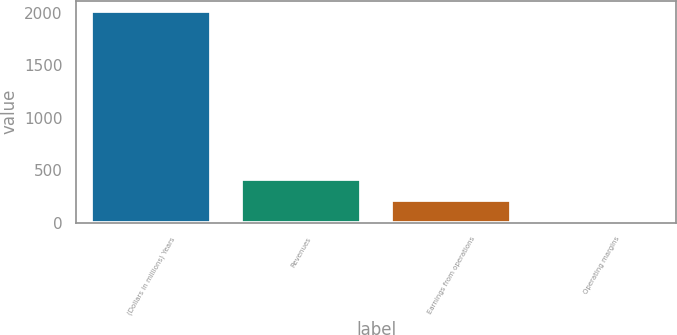Convert chart to OTSL. <chart><loc_0><loc_0><loc_500><loc_500><bar_chart><fcel>(Dollars in millions) Years<fcel>Revenues<fcel>Earnings from operations<fcel>Operating margins<nl><fcel>2016<fcel>419.2<fcel>219.6<fcel>20<nl></chart> 